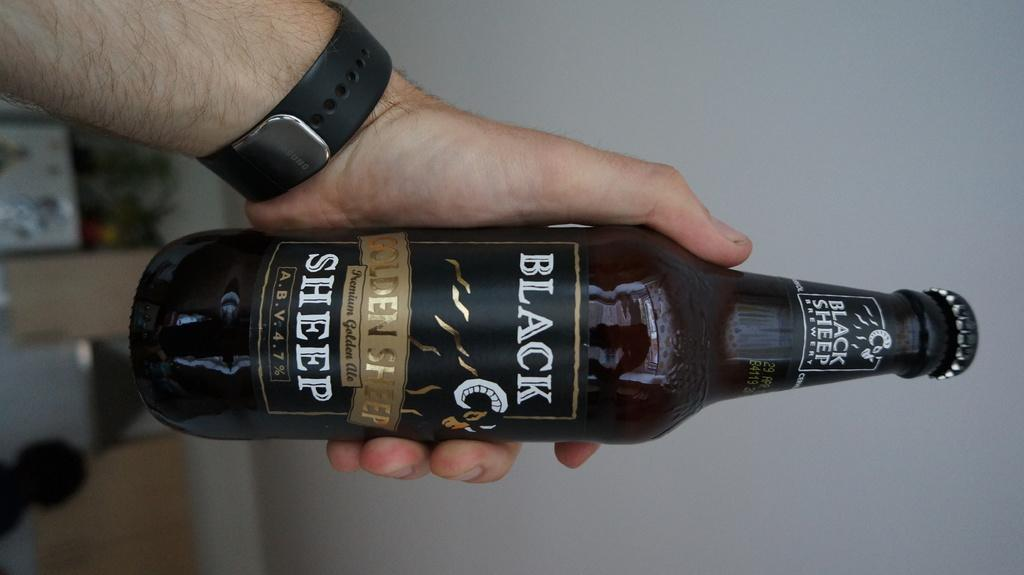Provide a one-sentence caption for the provided image. Person holding a beer can which says Black Sheep on it. 